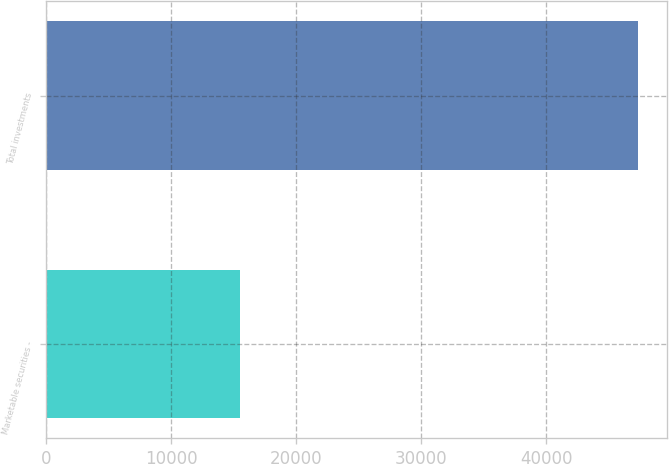<chart> <loc_0><loc_0><loc_500><loc_500><bar_chart><fcel>Marketable securities -<fcel>Total investments<nl><fcel>15510<fcel>47304<nl></chart> 